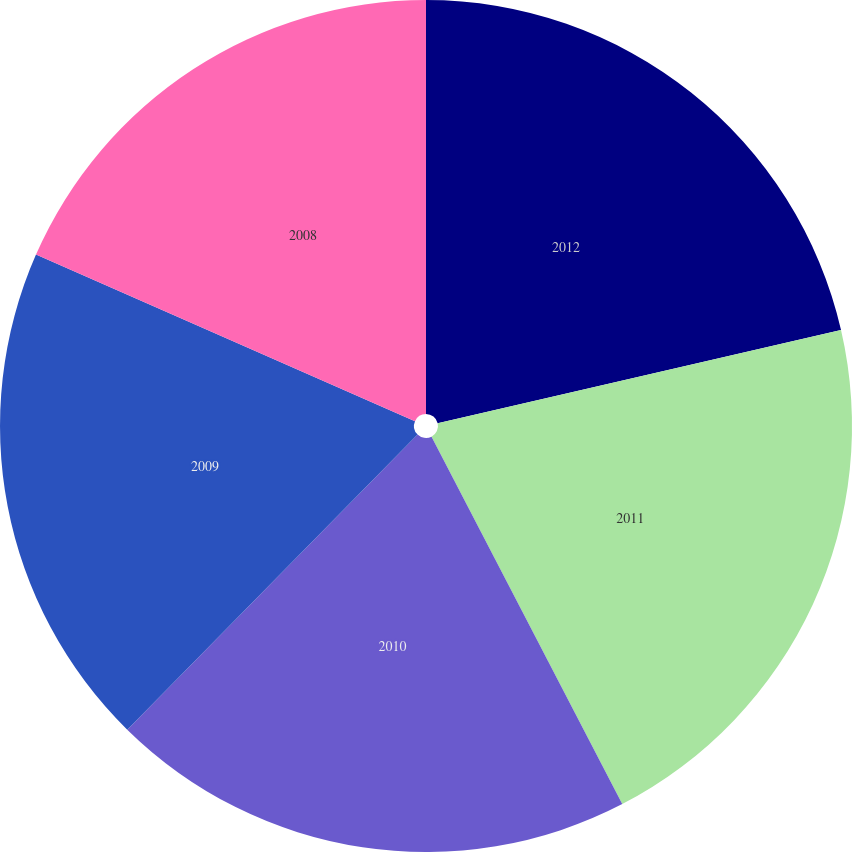<chart> <loc_0><loc_0><loc_500><loc_500><pie_chart><fcel>2012<fcel>2011<fcel>2010<fcel>2009<fcel>2008<nl><fcel>21.38%<fcel>21.0%<fcel>19.99%<fcel>19.22%<fcel>18.41%<nl></chart> 